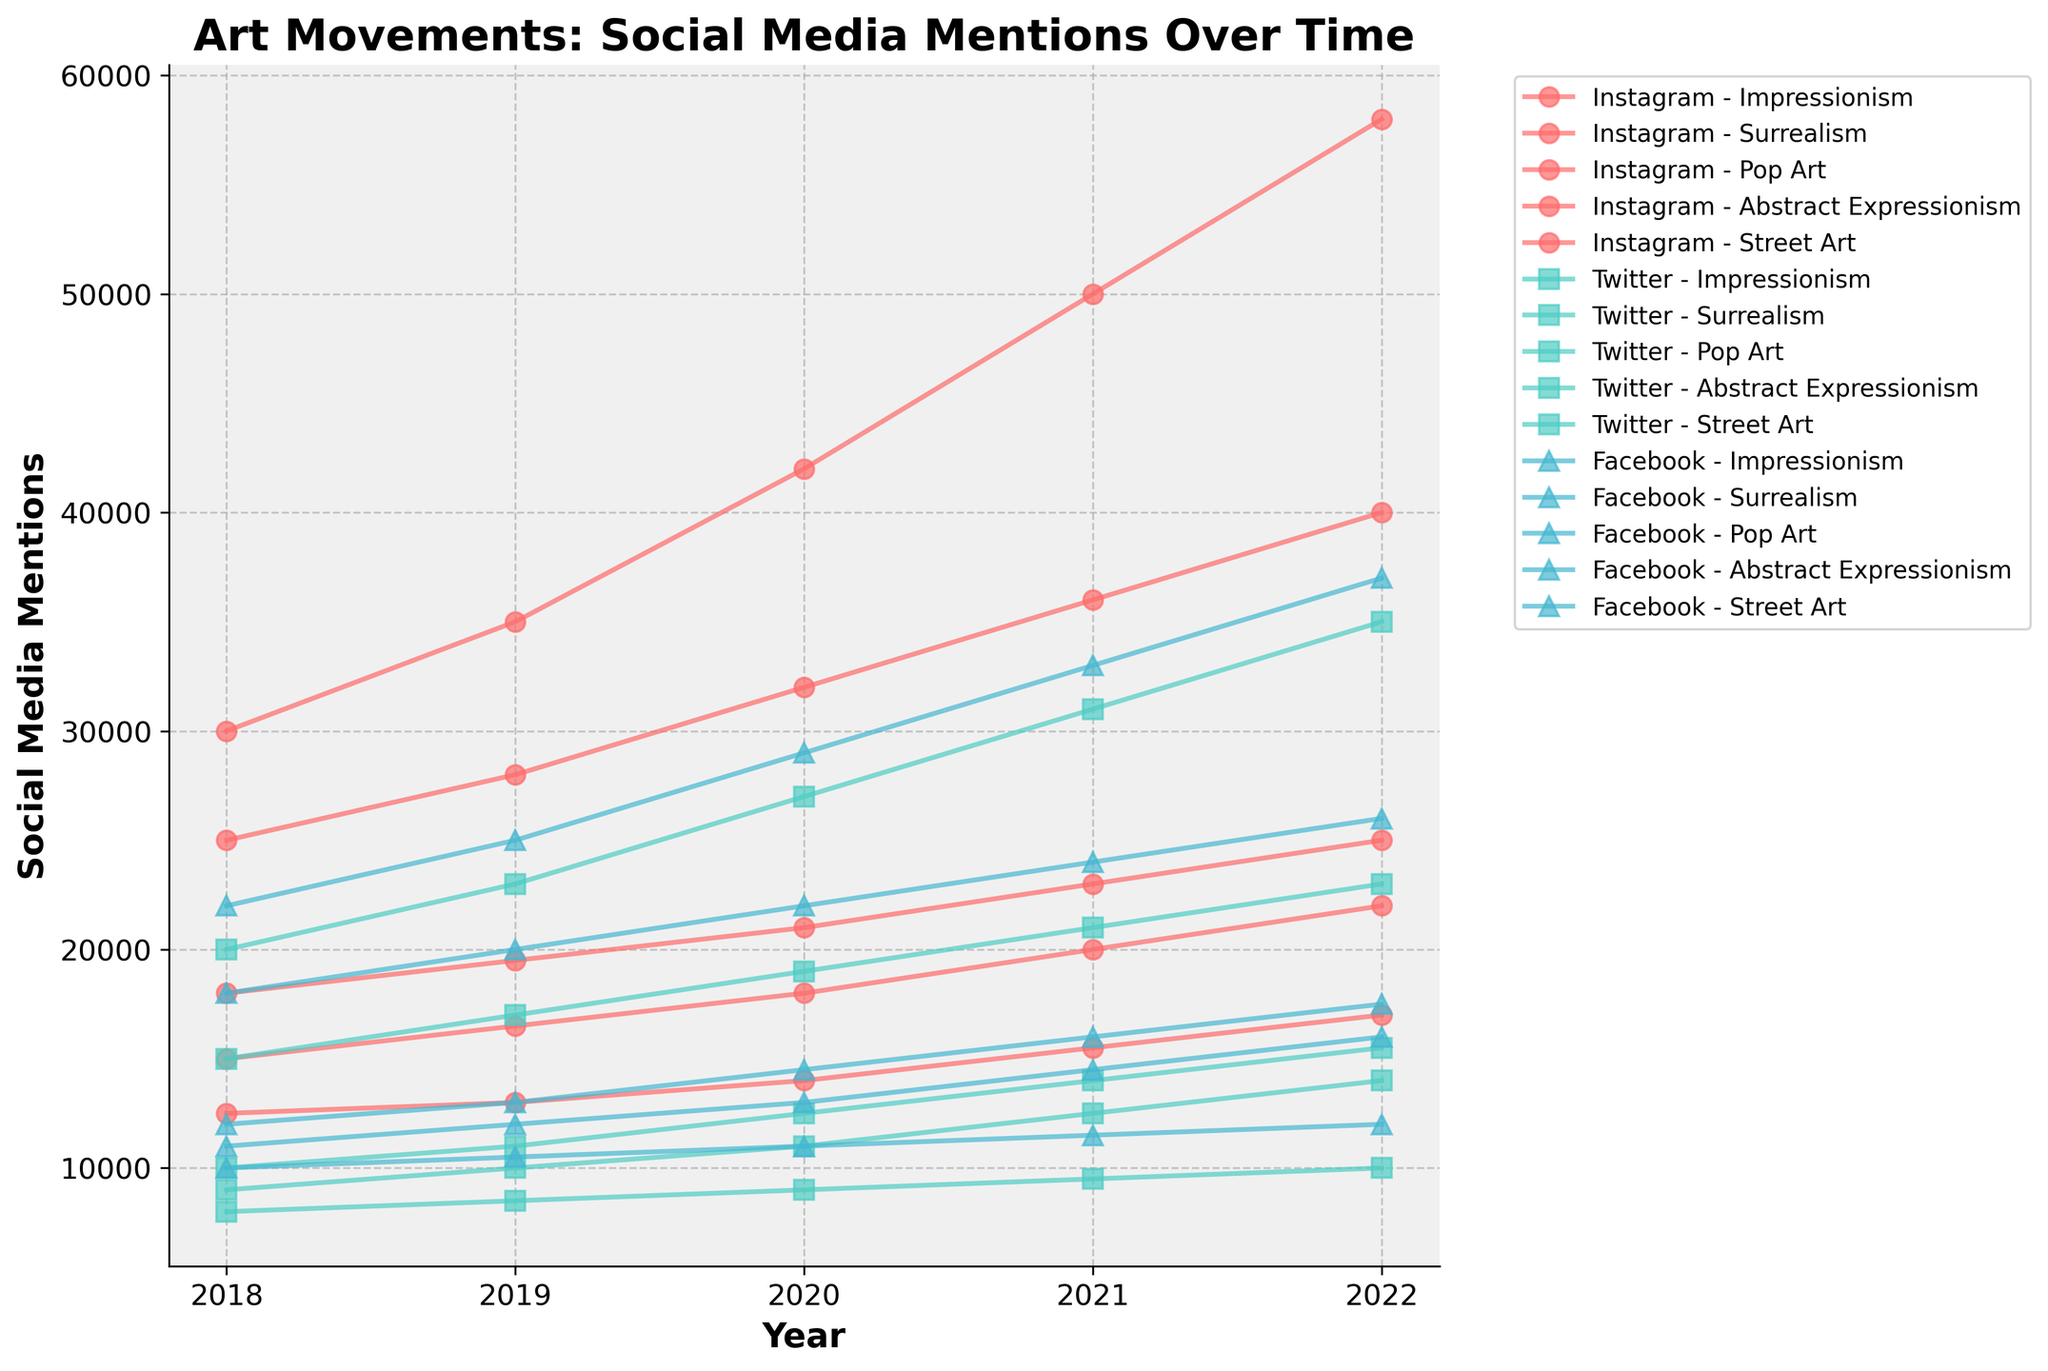What year did Instagram see the highest mentions for Street Art? The highest point for Instagram and Street Art can be identified by tracing the Street Art line to its peak on the Instagram portion of the plot.
Answer: 2022 Compare Surrealism mentions on Twitter in 2018 to 2022. Which year had more mentions? Compare the points on the Twitter line for Surrealism between 2018 and 2022. The higher point indicates the year with more mentions.
Answer: 2022 Which platform had the highest mentions for Pop Art in 2020? Check the different lines representing the three platforms in 2020 for Pop Art. The highest point will indicate the platform.
Answer: Instagram Calculate the average mentions for Abstract Expressionism on Facebook from 2018 to 2022. Average is calculated by summing mentions for each year from 2018 to 2022, and then dividing by the number of years (5). (11000+12000+13000+14500+16000) / 5 = 13200
Answer: 13200 How do the mentions of Impressionism on Instagram in 2020 compare to 2019? Find the points for Impressionism on Instagram for both years and compare their heights on the graph. The higher point indicates more mentions.
Answer: Higher in 2020 Which art movement saw the largest increase on Twitter from 2018 to 2022? Subtract the number of mentions in 2018 from 2022 for each art movement on Twitter. The largest difference indicates the biggest increase.
Answer: Street Art Compare the total mentions for Surrealism across all platforms in 2020. Which platform had the lowest total mentions? Sum the mentions for Surrealism on all platforms in 2020 and compare them. The platform with the smallest total has the lowest mentions.
Answer: Twitter On which year did Facebook record the highest number of mentions for Pop Art? Check the points along the Facebook line for Pop Art across all years and identify the peak.
Answer: 2022 Between Instagram and Twitter, which platform had a greater increase in Surrealism mentions from 2018 to 2022? Subtract the mentions in 2018 from 2022 for both platforms, and compare the increments. (25000 - 18000 for Instagram, 15500 - 10000 for Twitter).
Answer: Instagram What is the total sum of Street Art mentions on Instagram from 2018 to 2022? Add up all mentions for Street Art on Instagram over the given years. (30000 + 35000 + 42000 + 50000 + 58000) = 215000
Answer: 215000 